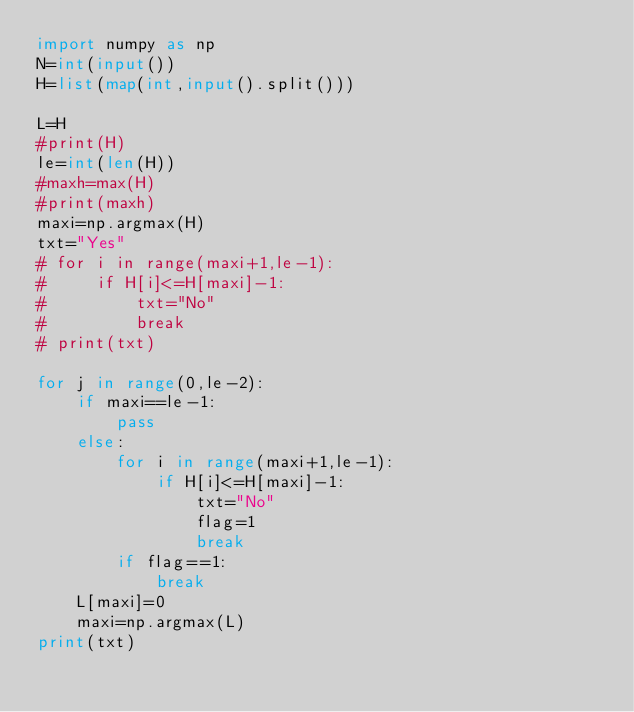<code> <loc_0><loc_0><loc_500><loc_500><_Python_>import numpy as np
N=int(input())
H=list(map(int,input().split()))

L=H
#print(H)
le=int(len(H))
#maxh=max(H)
#print(maxh)
maxi=np.argmax(H)
txt="Yes"
# for i in range(maxi+1,le-1):
#     if H[i]<=H[maxi]-1:
#         txt="No"
#         break
# print(txt)

for j in range(0,le-2):
    if maxi==le-1:
        pass
    else:
        for i in range(maxi+1,le-1):
            if H[i]<=H[maxi]-1:
                txt="No"
                flag=1
                break
        if flag==1:
            break
    L[maxi]=0
    maxi=np.argmax(L)
print(txt)
</code> 